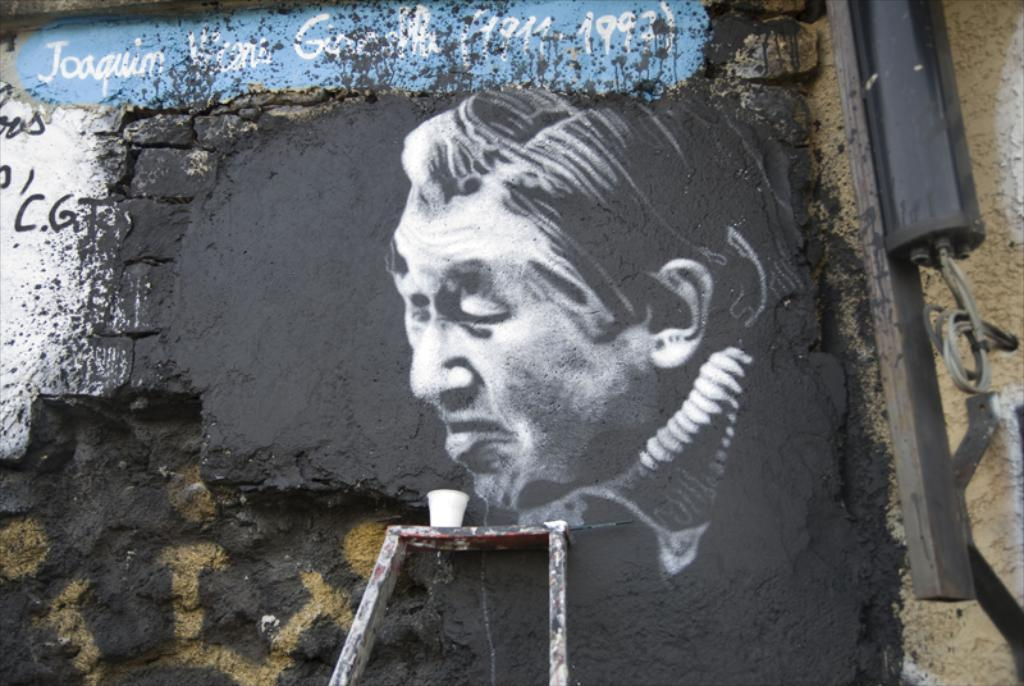What type of artwork can be seen on the wall in the image? There is graffiti on the wall in the image. What is written or depicted at the top of the image? There is text visible at the top of the image. What object is located on the right side of the image? There is a metal rod on the right side of the image. What is being used to support something at the bottom of the image? There is a ladder at the bottom of the image, and glass is placed on the ladder. Can you see any thumbs in the image? There are no thumbs visible in the image. What action is being performed by the cemetery in the image? There is no cemetery present in the image, so no action can be attributed to it. 